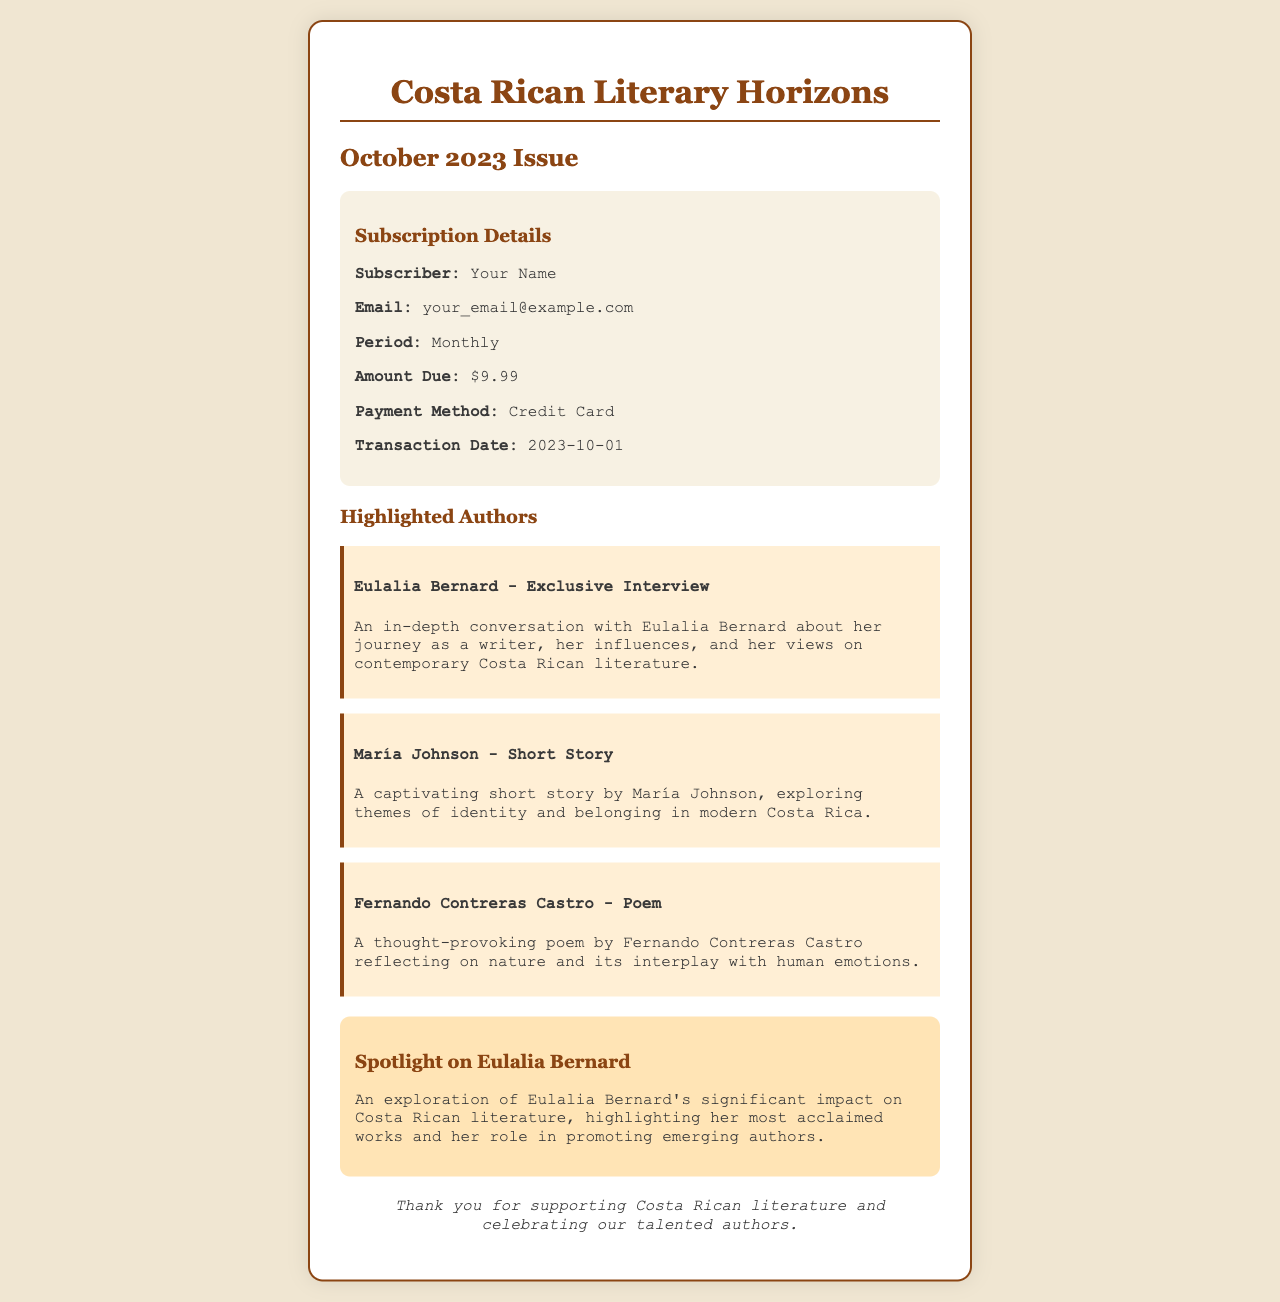What is the name of the magazine? The title of the magazine appears prominently at the top of the receipt, indicating the publication's identity.
Answer: Costa Rican Literary Horizons What is the issue date of this receipt? The receipt explicitly states the issue date just below the magazine title, reflecting the release time of the subscription.
Answer: October 2023 Who is the subscriber? The name of the subscriber is indicated in the subscription details section of the receipt.
Answer: Your Name What is the amount due for the subscription? The amount due is specifically mentioned in the subscription details, representing the cost for the monthly subscription.
Answer: $9.99 What is the payment method used? The payment method is listed in the subscription details, identifying how the subscription was paid.
Answer: Credit Card What is featured in the exclusive interview? The highlight section summarizes the content of the exclusive interview with a prominent author.
Answer: Eulalia Bernard - Exclusive Interview What type of content is in the "Spotlight on Eulalia Bernard"? The spotlight section provides an overview of the author's impact and significance in Costa Rican literature.
Answer: Significant impact on Costa Rican literature How many highlighted authors are mentioned? The highlights section lists the authors included, providing insight into the featured content.
Answer: Three What is the editorial note thanking subscribers for? The editorial note expresses gratitude towards subscribers for their contributions to the literary community.
Answer: Supporting Costa Rican literature 